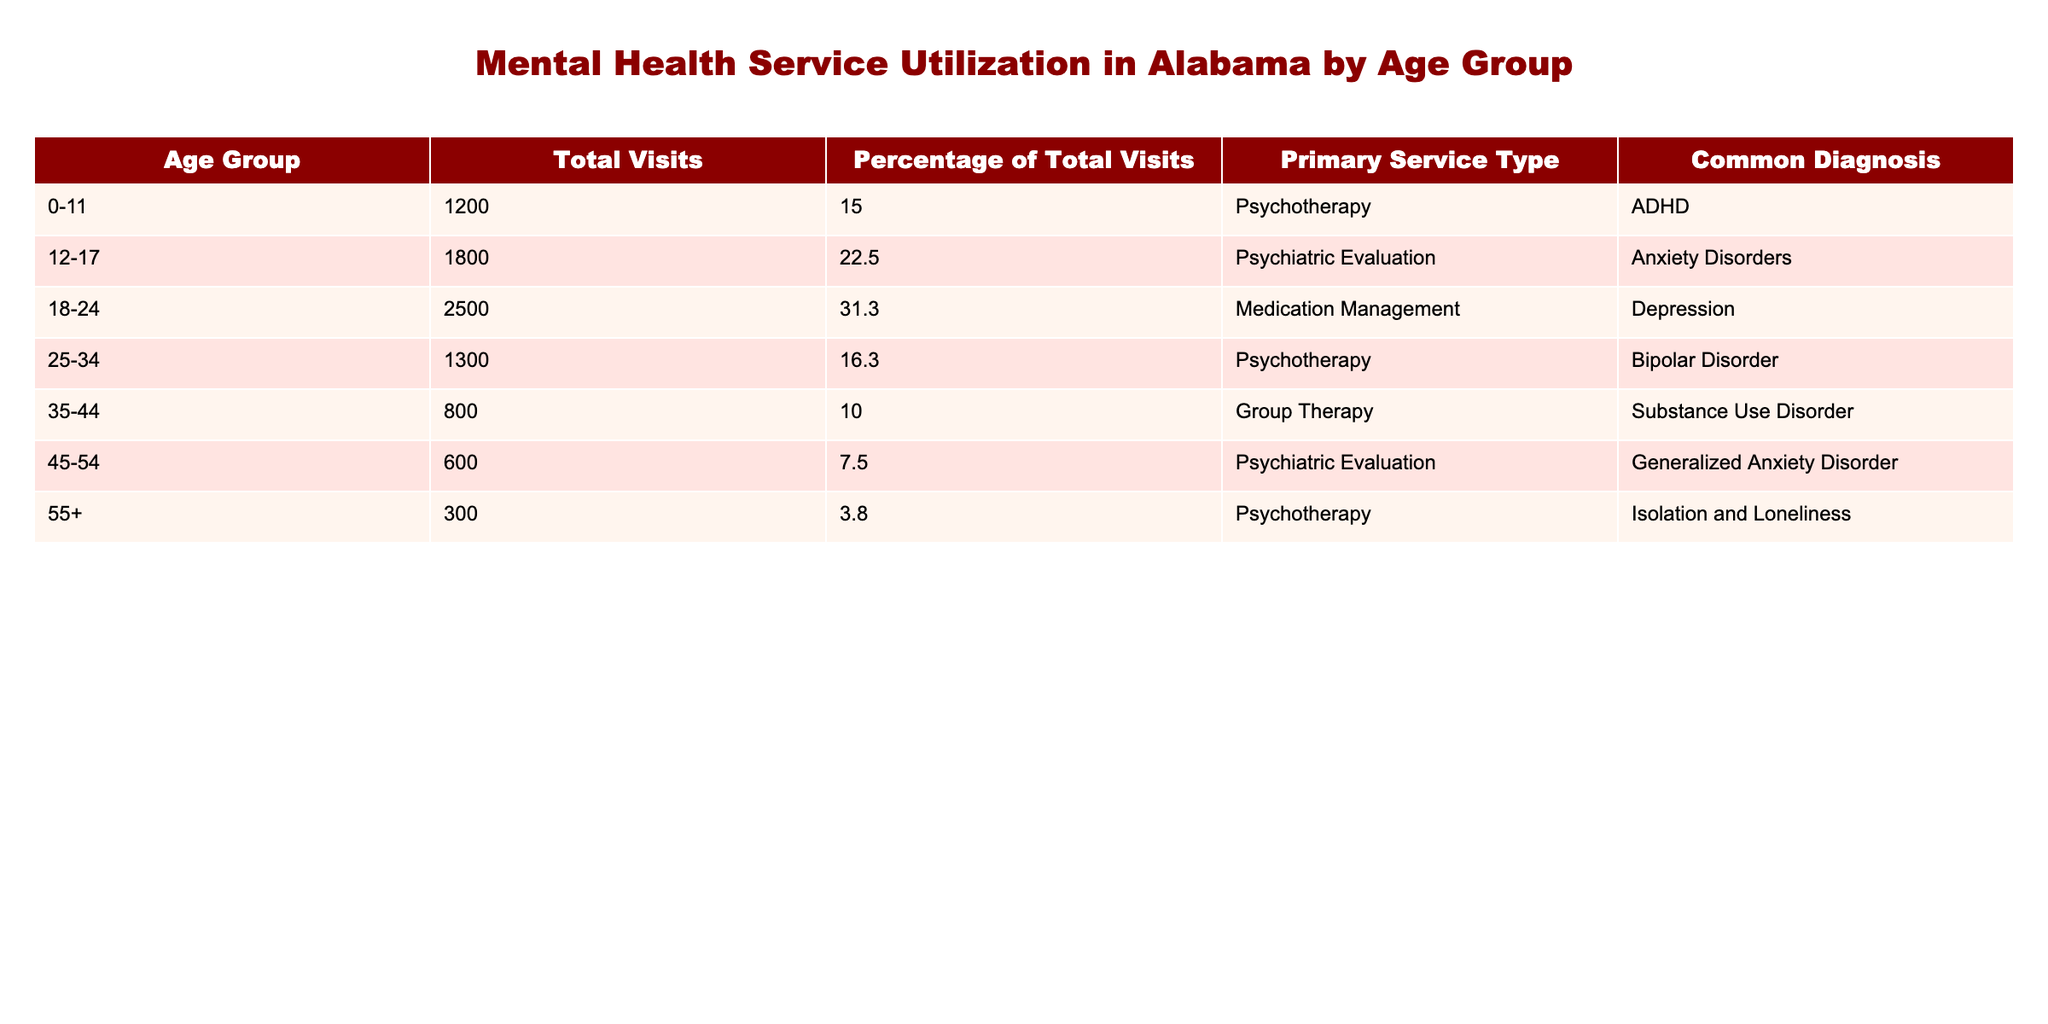What is the total number of visits for the age group 18-24? The table lists the total visits for each age group. Referring to the row for the age group 18-24, we see that the total number of visits is 2500.
Answer: 2500 What percentage of the total visits does the age group 45-54 account for? The age group 45-54 has a total of 600 visits, and the table shows its corresponding percentage of total visits as 7.5%.
Answer: 7.5% Which age group has the highest number of total visits and what is that number? By comparing the total visits across all age groups, the age group 18-24 has the highest number of total visits, which is 2500.
Answer: 2500 Is the primary service type for the age group 0-11 psychotherapy? According to the table, the primary service type for the age group 0-11 is indeed psychotherapy, matching the value in the relevant cell.
Answer: Yes How many visits were accounted for by the age group 25-34 compared to the age group 35-44? The table indicates that the age group 25-34 had 1300 visits while the age group 35-44 had 800 visits. Subtracting these, 1300 - 800 = 500 visits more for the 25-34 age group.
Answer: 500 What is the total number of visits for all age groups combined? By adding all the total visits from each age group: 1200 + 1800 + 2500 + 1300 + 800 + 600 + 300 = 8200. Hence the total visits for all groups combined is 8200.
Answer: 8200 Which diagnosis is most common among those who received medication management? The table indicates the common diagnosis for age group 18-24, which is depression. Thus, depression is the most common diagnosis for this primary service type.
Answer: Depression What percentage of the total visits were made by the age group 55 and older? The age group 55+ had 300 visits, which corresponds to 3.8% of the total visits as indicated in the table.
Answer: 3.8% Is the total number of visits for teenagers aged 12-17 greater than that for adults aged 45-54? The table shows 1800 visits for age group 12-17, and 600 visits for age group 45-54. Since 1800 is greater than 600, the statement is true.
Answer: Yes 